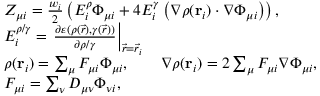<formula> <loc_0><loc_0><loc_500><loc_500>\begin{array} { r l } & { Z _ { \mu i } = \frac { w _ { i } } { 2 } \left ( E _ { i } ^ { \rho } \Phi _ { \mu i } + 4 E _ { i } ^ { \gamma } \left ( \nabla \rho ( r _ { i } ) \cdot \nabla \Phi _ { \mu i } \right ) \right ) , } \\ & { E _ { i } ^ { \rho / \gamma } = \frac { \partial \varepsilon ( \rho ( \vec { r } ) , \gamma ( \vec { r } ) ) } { \partial \rho / \gamma } \right | _ { \vec { r } = \vec { r } _ { i } } } \\ & { \rho ( r _ { i } ) = \sum _ { \mu } F _ { \mu i } \Phi _ { \mu i } , \quad \nabla \rho ( r _ { i } ) = 2 \sum _ { \mu } F _ { \mu i } \nabla \Phi _ { \mu i } , } \\ & { F _ { \mu i } = \sum _ { \nu } D _ { \mu \nu } \Phi _ { \nu i } , } \end{array}</formula> 